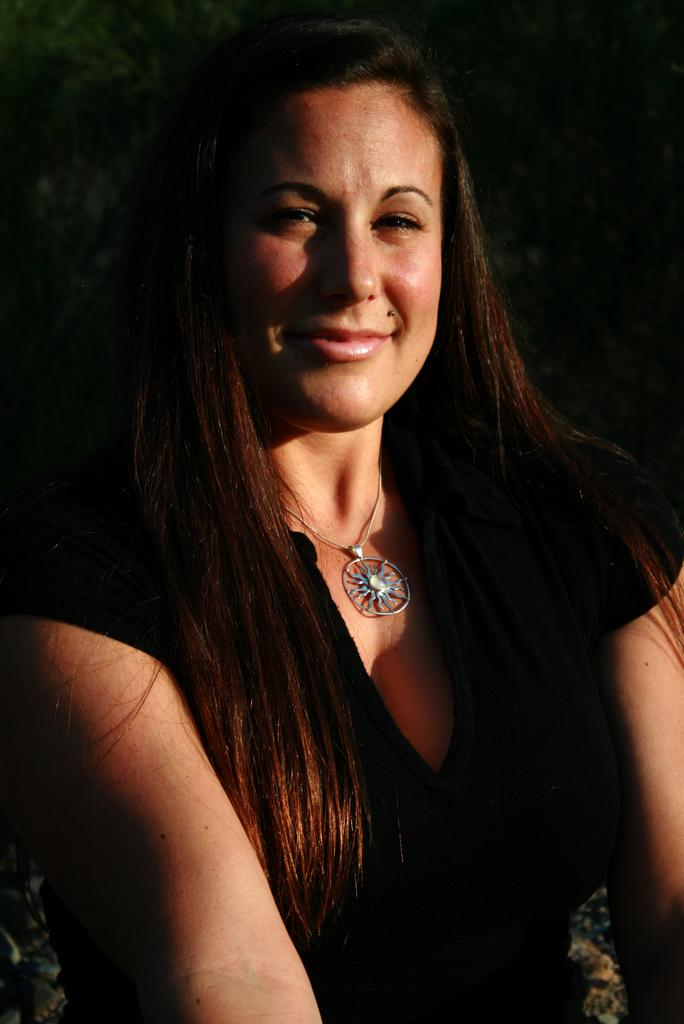Who is the main subject in the image? There is a woman in the image. What is the woman wearing? The woman is wearing a black dress. What expression does the woman have? The woman is smiling. What type of jewelry is the woman wearing? There is a round locket chain around her neck. What is the color of the background in the image? The background of the image is black. What type of vegetable is the woman holding in the image? There is no vegetable present in the image; the woman is not holding anything. 